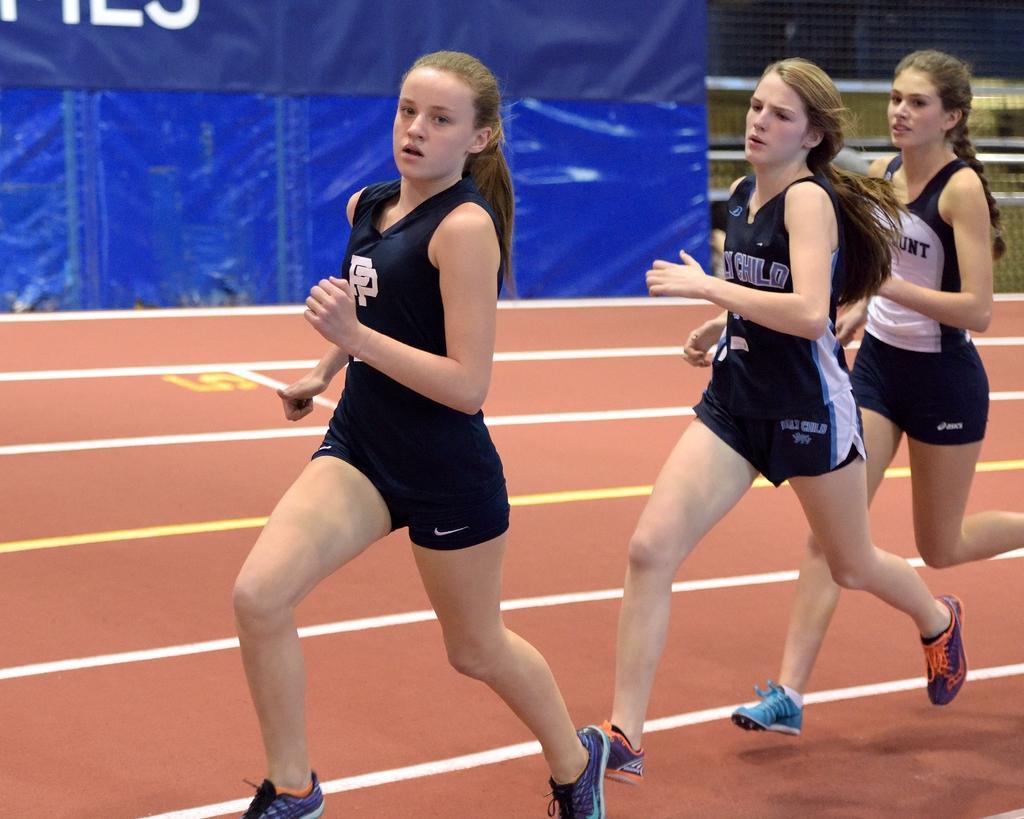Describe this image in one or two sentences. In this image there are three women running, there is a running track towards the bottom of the image, there is a number on the track, there is a fence towards the right of the image, there is a banner towards the top of the image, there is text on the banner. 